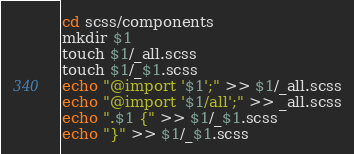<code> <loc_0><loc_0><loc_500><loc_500><_Bash_>cd scss/components
mkdir $1
touch $1/_all.scss
touch $1/_$1.scss
echo "@import '$1';" >> $1/_all.scss
echo "@import '$1/all';" >> _all.scss
echo ".$1 {" >> $1/_$1.scss
echo "}" >> $1/_$1.scss
</code> 